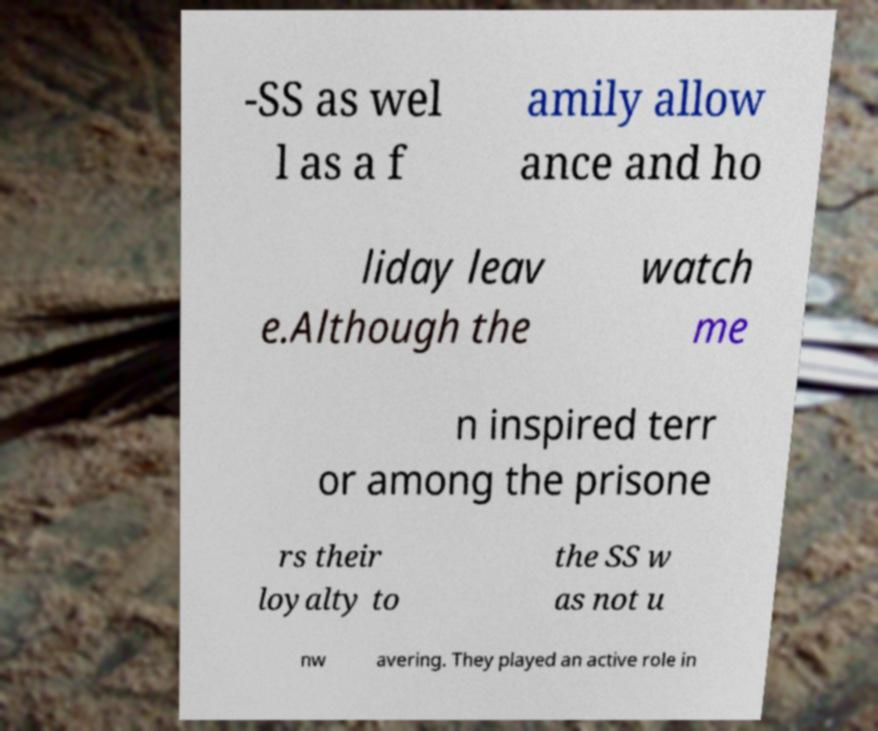There's text embedded in this image that I need extracted. Can you transcribe it verbatim? -SS as wel l as a f amily allow ance and ho liday leav e.Although the watch me n inspired terr or among the prisone rs their loyalty to the SS w as not u nw avering. They played an active role in 